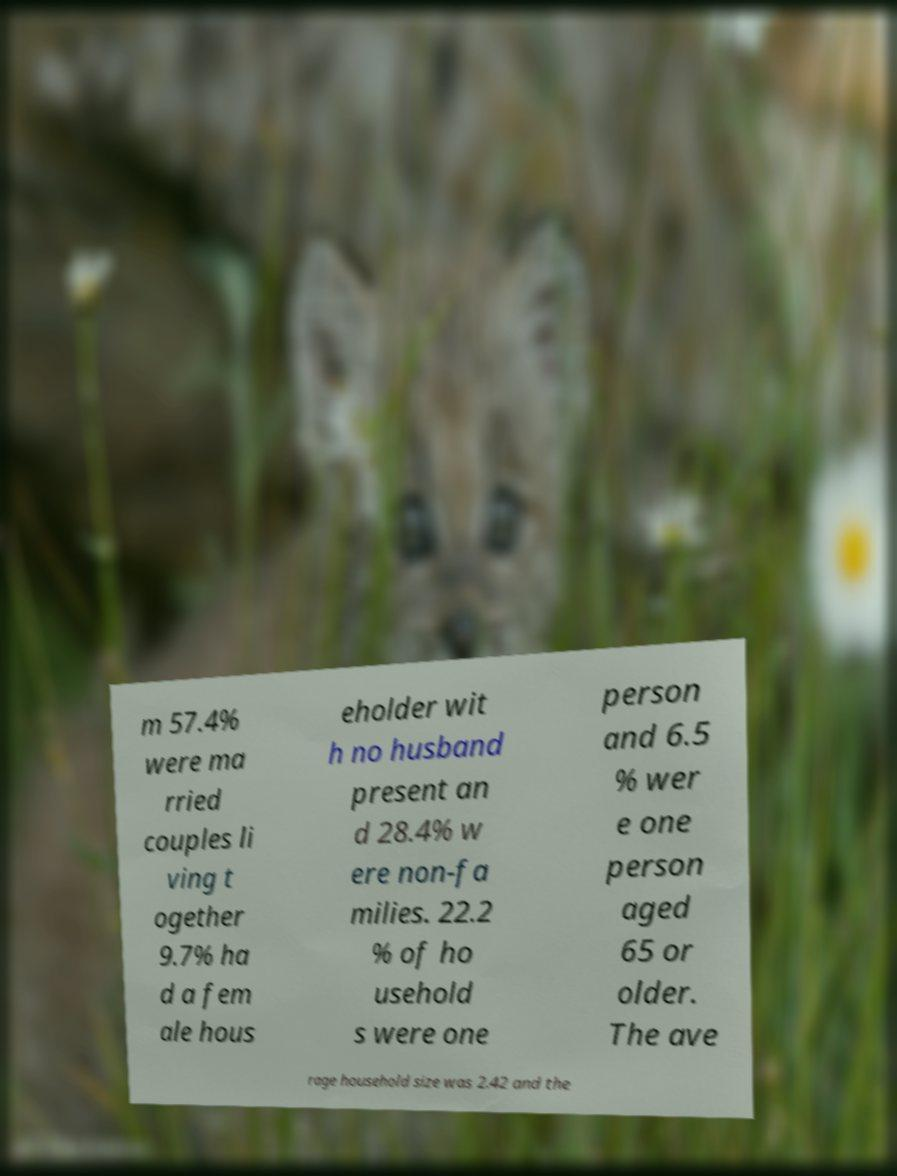What messages or text are displayed in this image? I need them in a readable, typed format. m 57.4% were ma rried couples li ving t ogether 9.7% ha d a fem ale hous eholder wit h no husband present an d 28.4% w ere non-fa milies. 22.2 % of ho usehold s were one person and 6.5 % wer e one person aged 65 or older. The ave rage household size was 2.42 and the 